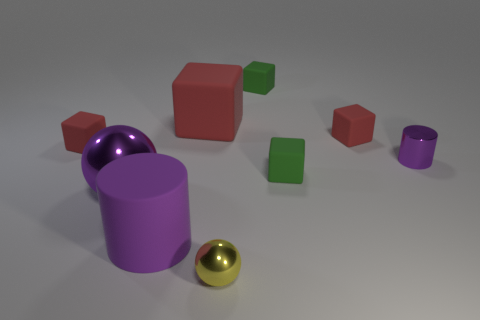Is the shape of the small yellow object the same as the big purple shiny object?
Offer a terse response. Yes. There is a large purple thing that is the same shape as the tiny purple object; what is it made of?
Provide a short and direct response. Rubber. What number of large matte things have the same color as the big cylinder?
Give a very brief answer. 0. What is the size of the purple ball that is the same material as the tiny yellow ball?
Make the answer very short. Large. What number of red things are either tiny rubber cubes or small balls?
Give a very brief answer. 2. How many tiny red rubber cubes are in front of the tiny matte object left of the large purple metal ball?
Give a very brief answer. 0. Are there more large purple objects that are in front of the large cube than tiny yellow objects that are behind the big purple ball?
Your answer should be compact. Yes. What is the small ball made of?
Offer a terse response. Metal. Is there a gray matte cylinder of the same size as the purple metallic cylinder?
Your response must be concise. No. There is a cylinder that is the same size as the yellow thing; what is it made of?
Offer a very short reply. Metal. 